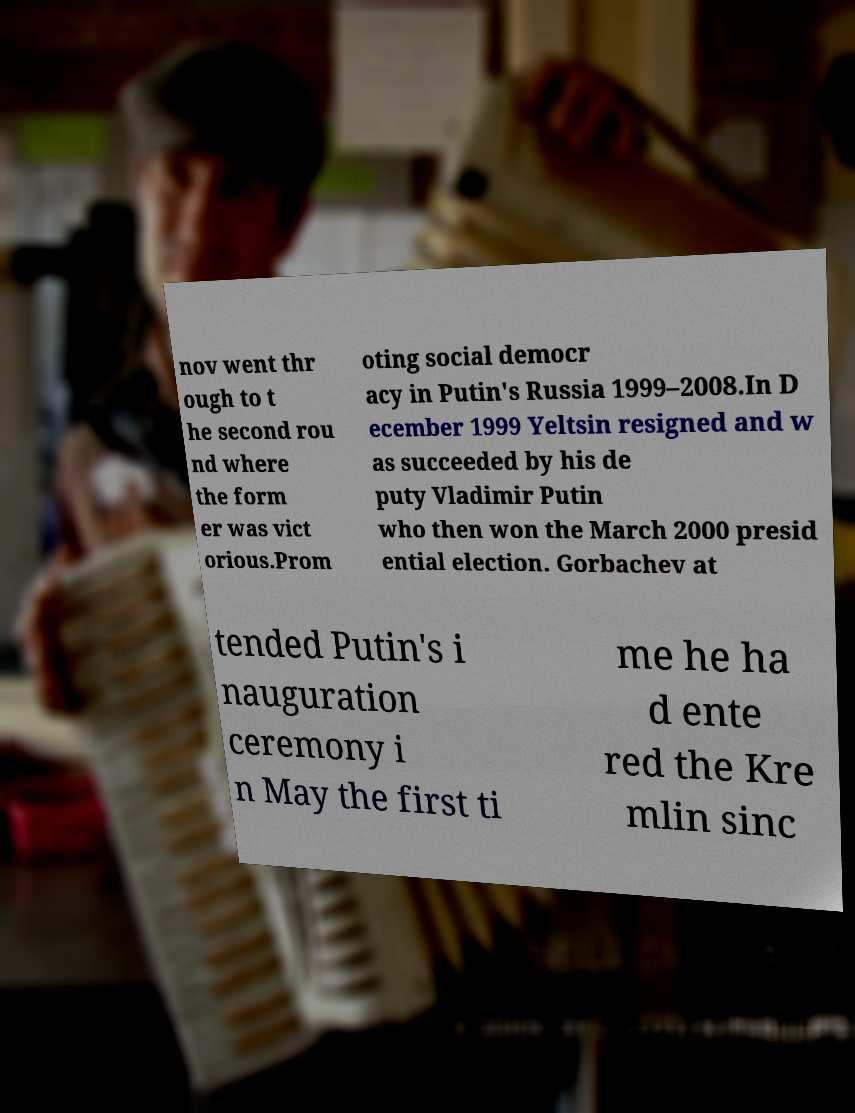Could you assist in decoding the text presented in this image and type it out clearly? nov went thr ough to t he second rou nd where the form er was vict orious.Prom oting social democr acy in Putin's Russia 1999–2008.In D ecember 1999 Yeltsin resigned and w as succeeded by his de puty Vladimir Putin who then won the March 2000 presid ential election. Gorbachev at tended Putin's i nauguration ceremony i n May the first ti me he ha d ente red the Kre mlin sinc 